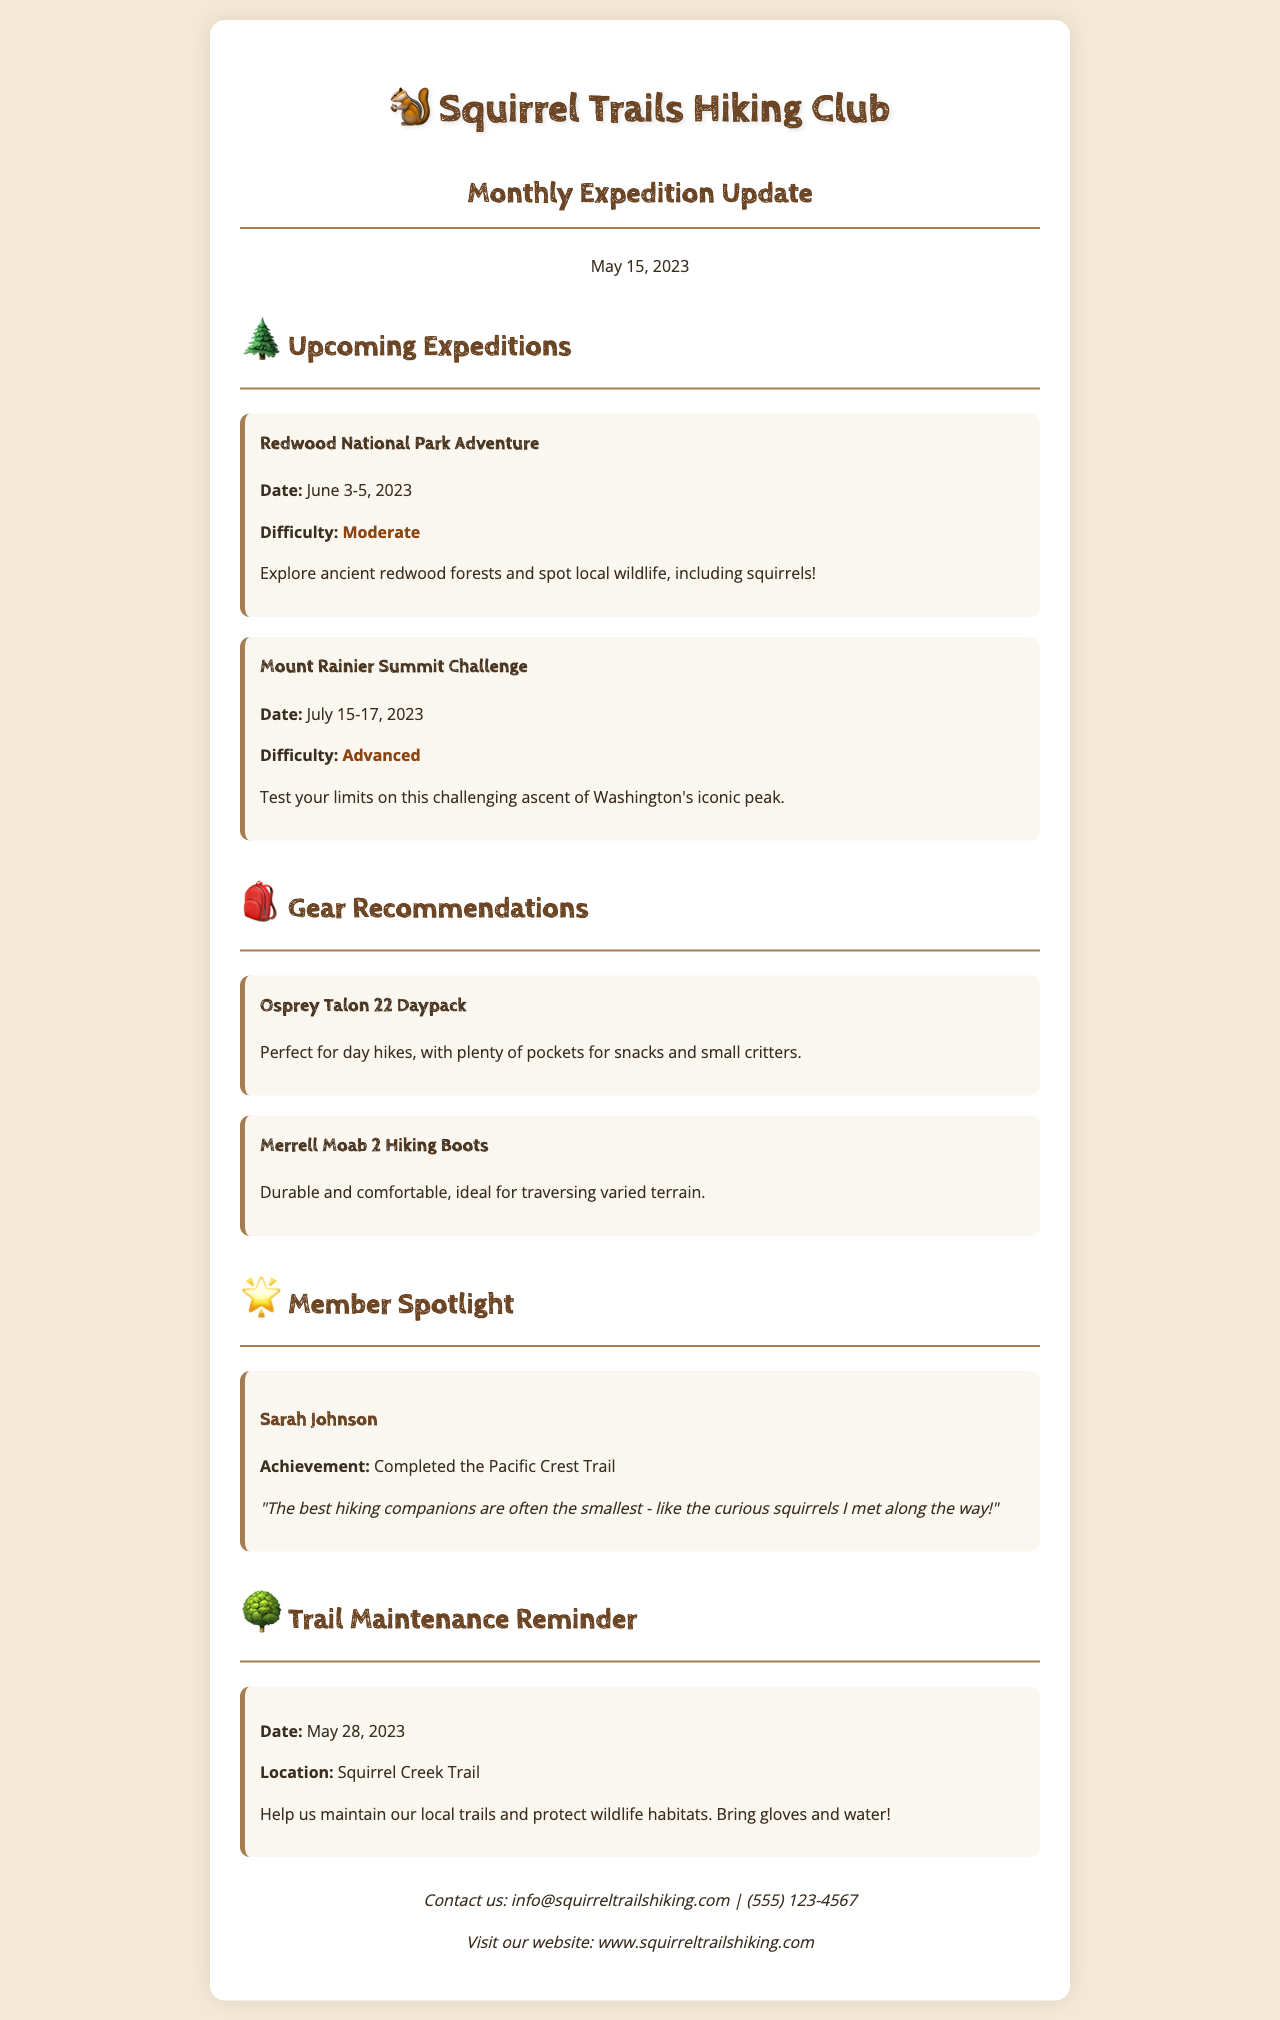What is the title of the newsletter? The title of the newsletter is indicated at the top of the document as "Squirrel Trails Hiking Club Newsletter."
Answer: Squirrel Trails Hiking Club Newsletter What is the date of the Redwood National Park Adventure? The date for the Redwood National Park Adventure is stated in the expedition section of the document.
Answer: June 3-5, 2023 Who is the member spotlighted in this newsletter? The member spotlight section provides the name of the featured member along with their achievement.
Answer: Sarah Johnson What gear is recommended for day hikes? The gear recommendations section includes specific items suited for hiking.
Answer: Osprey Talon 22 Daypack What is the difficulty level of the Mount Rainier Summit Challenge? The difficulty level for the Mount Rainier Summit Challenge is stated in the expedition details.
Answer: Advanced What is the location for the trail maintenance reminder? The trail maintenance reminder includes the location where the activity will take place.
Answer: Squirrel Creek Trail How many days is the Mount Rainier Summit Challenge expedition? The duration of this challenge is indicated in the expedition details provided in the newsletter.
Answer: 3 days What should volunteers bring for trail maintenance? The trail maintenance reminder specifies items that participants should bring.
Answer: Gloves and water 